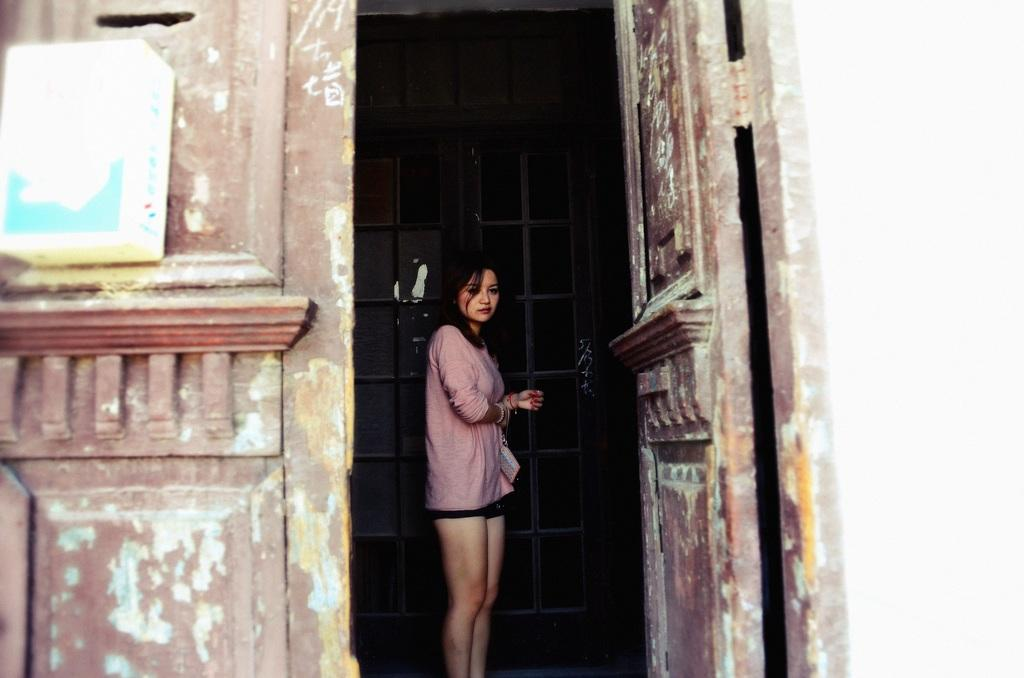What is the main subject of the image? There is a woman standing in the image. What objects or features can be seen in the image besides the woman? There are elements that resemble doors and an object that looks like a board in the image. Can you describe the door-like elements in the image? There is a kind of door visible in the background of the image. What type of road can be seen in the image? There is no road present in the image. Can you tell me about the discussion happening between the woman and the wheel in the image? There is no wheel or discussion present in the image. 